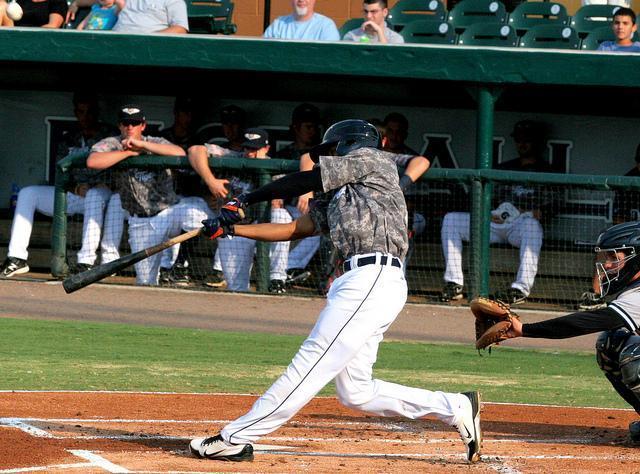How many people can you see?
Give a very brief answer. 9. 